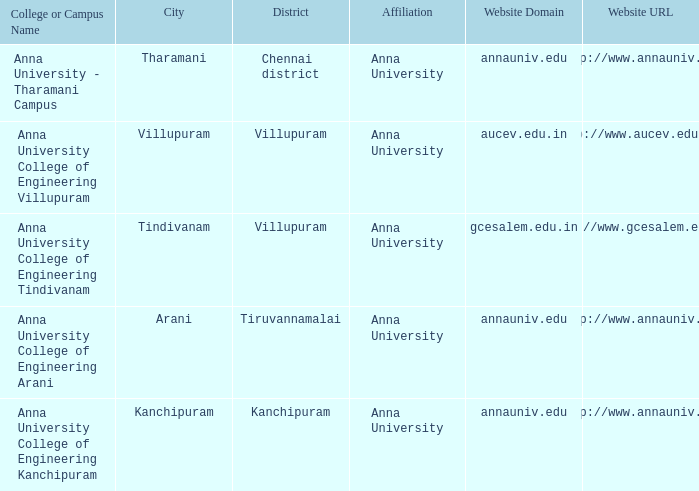What District has a Location of tharamani? Chennai district. 